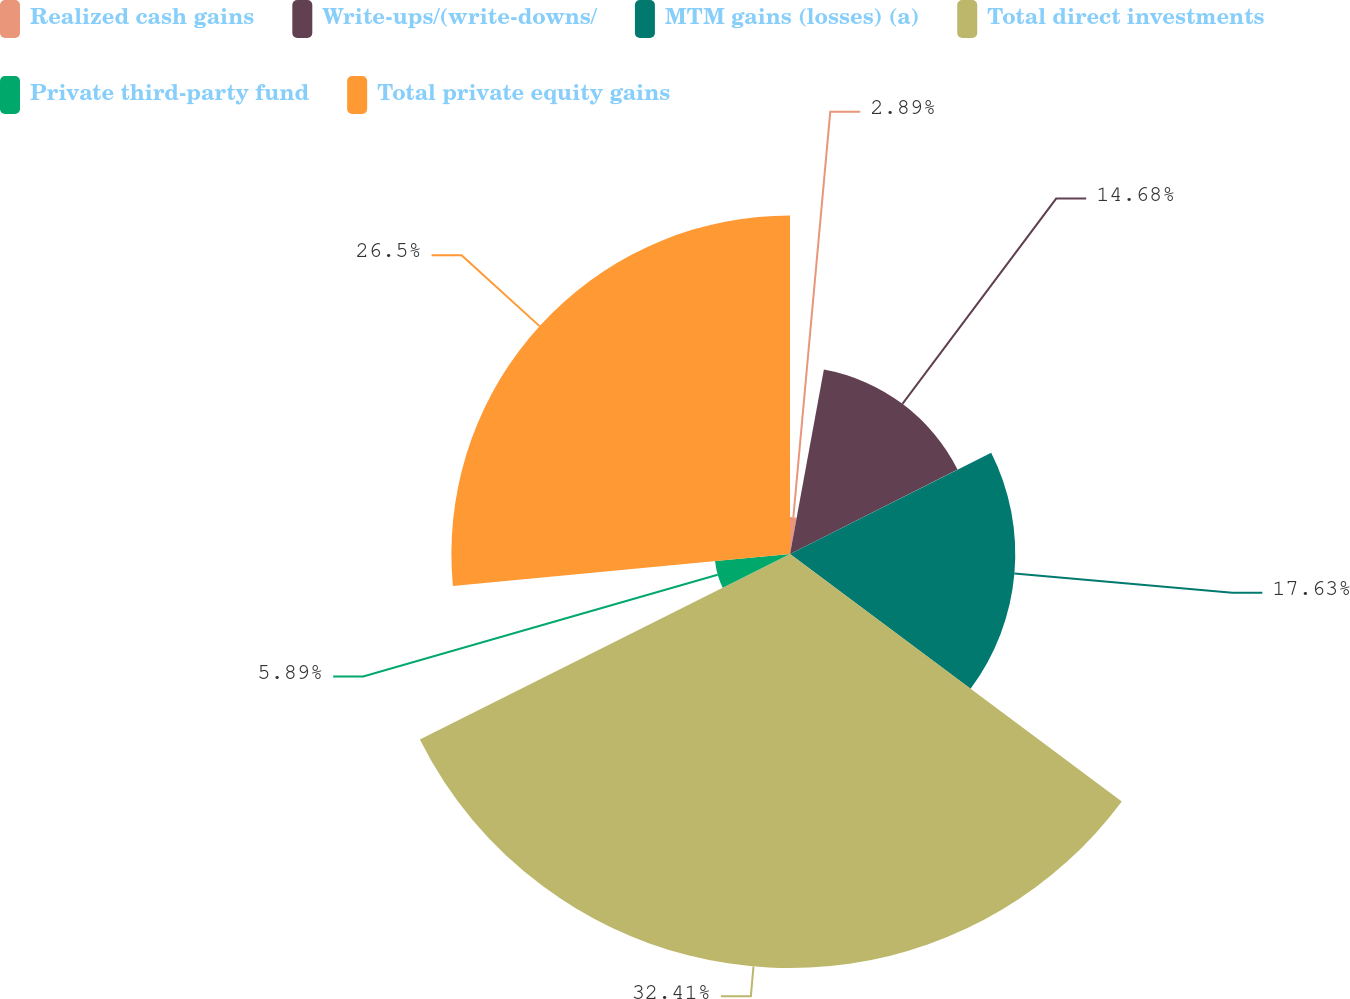Convert chart. <chart><loc_0><loc_0><loc_500><loc_500><pie_chart><fcel>Realized cash gains<fcel>Write-ups/(write-downs/<fcel>MTM gains (losses) (a)<fcel>Total direct investments<fcel>Private third-party fund<fcel>Total private equity gains<nl><fcel>2.89%<fcel>14.68%<fcel>17.63%<fcel>32.4%<fcel>5.89%<fcel>26.5%<nl></chart> 